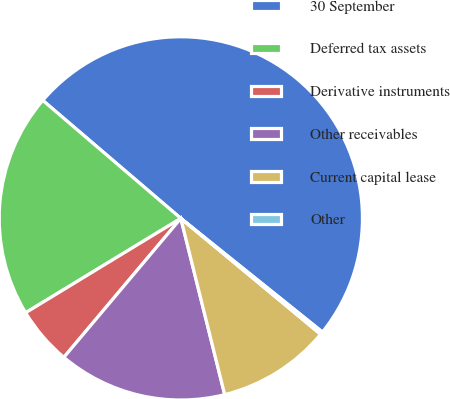<chart> <loc_0><loc_0><loc_500><loc_500><pie_chart><fcel>30 September<fcel>Deferred tax assets<fcel>Derivative instruments<fcel>Other receivables<fcel>Current capital lease<fcel>Other<nl><fcel>49.51%<fcel>19.95%<fcel>5.17%<fcel>15.02%<fcel>10.1%<fcel>0.25%<nl></chart> 